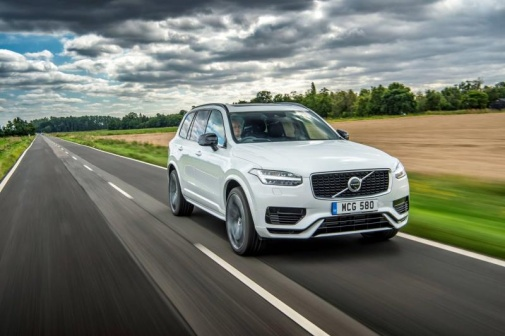What is the significance of the license plate on this vehicle? The license plate 'MC6 580' might not have any particular significance beyond its function as a vehicle identifier. However, sometimes license plates can hold personal or cultural significance to the owner, such as commemorating a special date, initials, or even a custom message if it’s a vanity plate. 